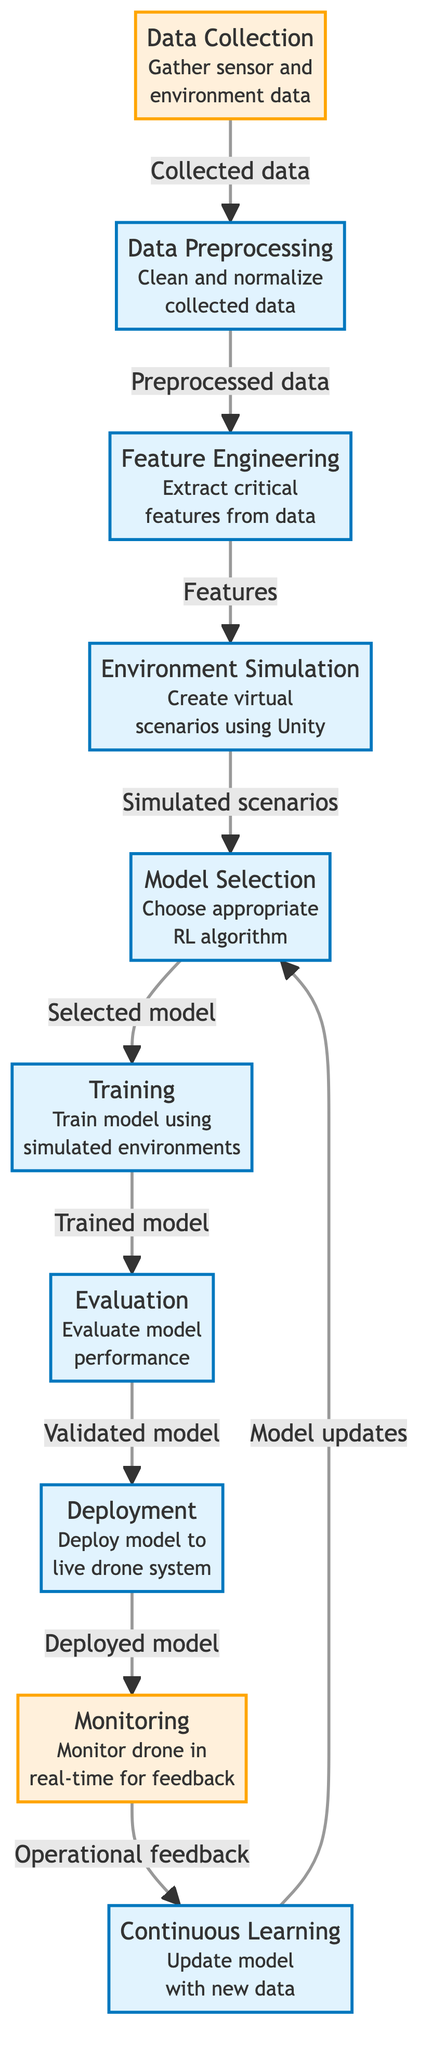What is the first step in the process map? The first step indicated in the diagram is "Data Collection," which gathers sensor and environment data.
Answer: Data Collection How many nodes are in the diagram? By counting the nodes listed in the diagram, we see there are ten nodes involved in the autonomous drone navigation process.
Answer: Ten What step follows "Evaluation"? According to the flow of the diagram, the step that follows "Evaluation" is "Deployment," where the model is deployed to the live drone system.
Answer: Deployment Which node is responsible for extracting critical features? The node responsible for extracting critical features from the data is "Feature Engineering." This is detailed in the description beneath the node.
Answer: Feature Engineering What type of feedback is monitored in the "Monitoring" step? The diagram specifies that "Monitoring" involves “Operational feedback,” which is crucial for the continuous improvement of the system.
Answer: Operational feedback Which two nodes connect directly with a feedback loop? The "Monitoring" node connects directly with "Continuous Learning," creating a feedback loop for updating the model with new data.
Answer: Monitoring and Continuous Learning What role does the "Environment Simulation" node play in the process? The "Environment Simulation" node creates virtual scenarios using Unity, which is essential for the training of the model in safe and controlled conditions.
Answer: Create virtual scenarios How does "Continuous Learning" influence "Model Selection"? "Continuous Learning" provides model updates based on new data collected during monitoring, which in turn influences the "Model Selection" process by choosing the most effective RL algorithm.
Answer: Provides model updates What is the last step in the diagram's process? The last step indicated in the process map is "Continuous Learning," which updates the model with new data to enhance performance over time.
Answer: Continuous Learning 